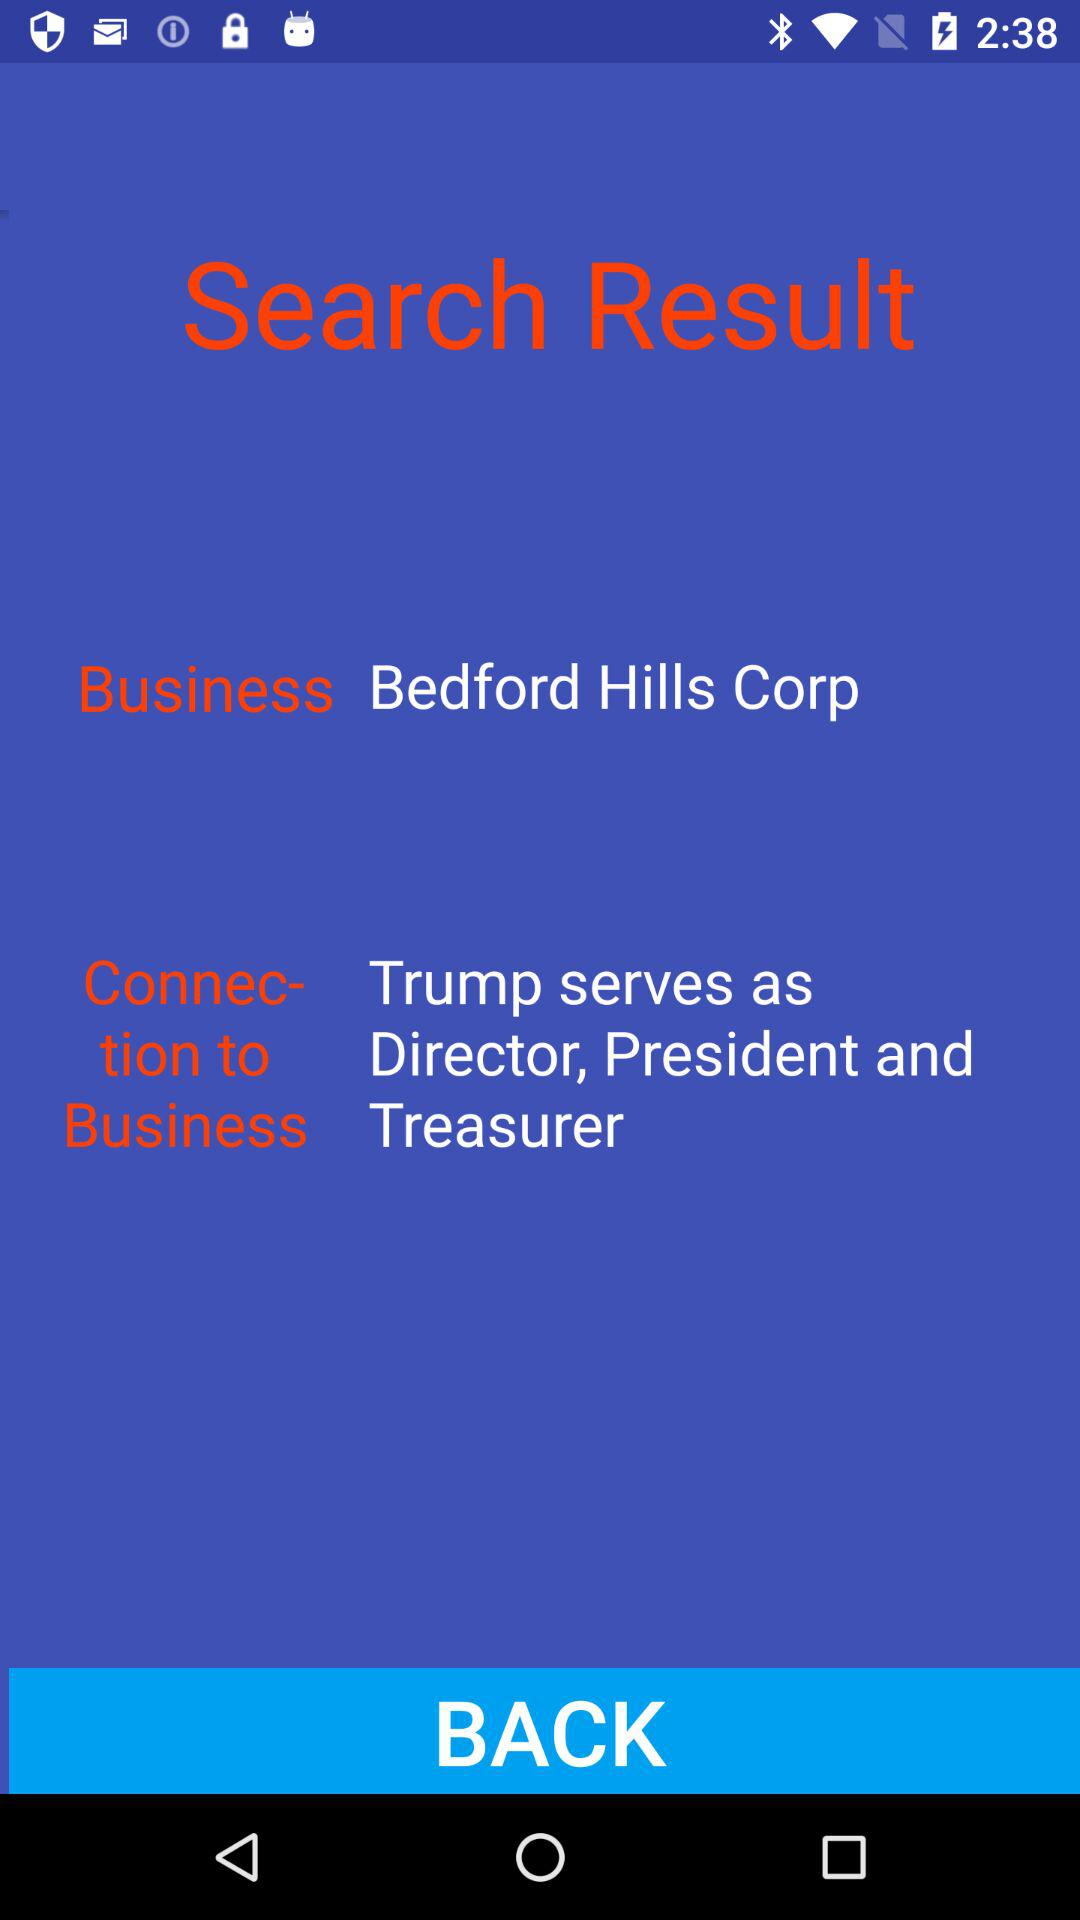What is the business name? The business name is "Bedford Hills Corp". 